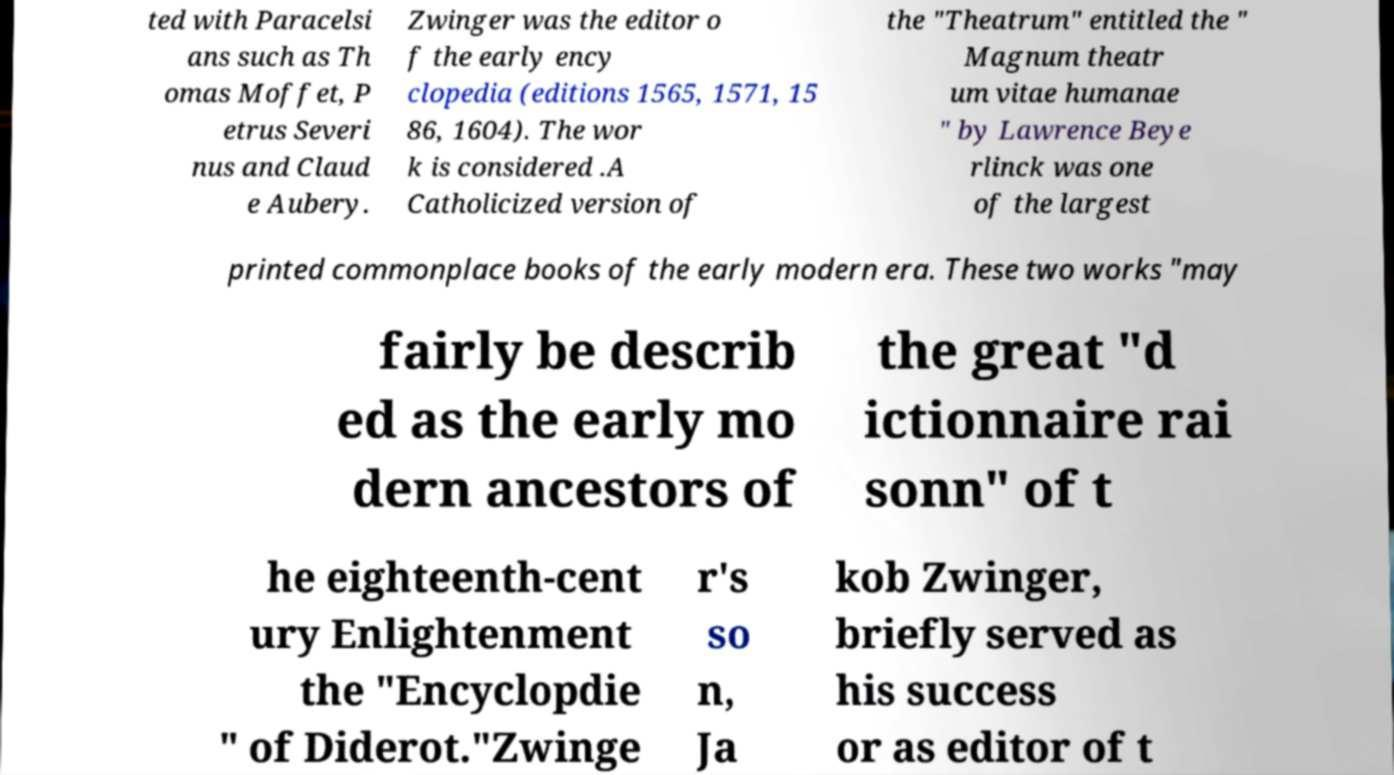Could you extract and type out the text from this image? ted with Paracelsi ans such as Th omas Moffet, P etrus Severi nus and Claud e Aubery. Zwinger was the editor o f the early ency clopedia (editions 1565, 1571, 15 86, 1604). The wor k is considered .A Catholicized version of the "Theatrum" entitled the " Magnum theatr um vitae humanae " by Lawrence Beye rlinck was one of the largest printed commonplace books of the early modern era. These two works "may fairly be describ ed as the early mo dern ancestors of the great "d ictionnaire rai sonn" of t he eighteenth-cent ury Enlightenment the "Encyclopdie " of Diderot."Zwinge r's so n, Ja kob Zwinger, briefly served as his success or as editor of t 